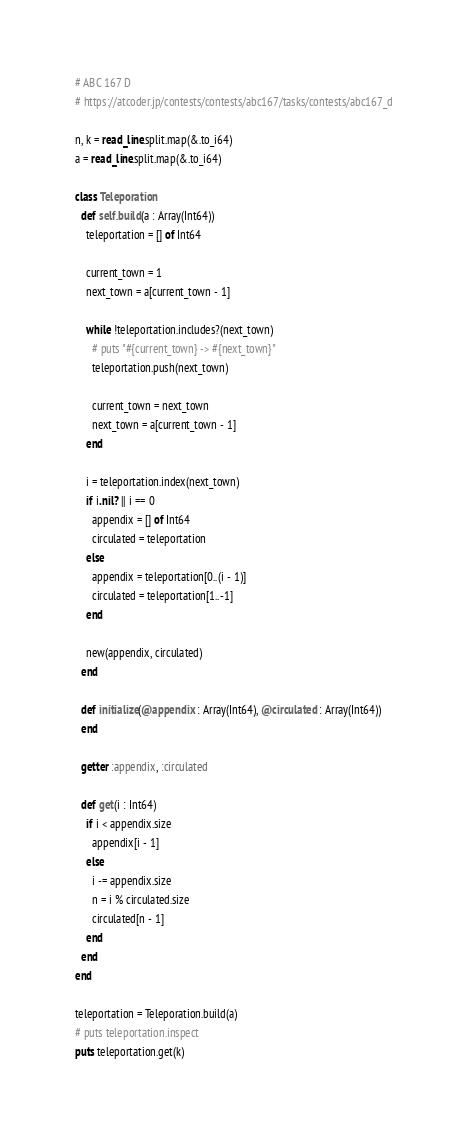<code> <loc_0><loc_0><loc_500><loc_500><_Crystal_># ABC 167 D
# https://atcoder.jp/contests/contests/abc167/tasks/contests/abc167_d

n, k = read_line.split.map(&.to_i64)
a = read_line.split.map(&.to_i64)

class Teleporation
  def self.build(a : Array(Int64))
    teleportation = [] of Int64

    current_town = 1
    next_town = a[current_town - 1]

    while !teleportation.includes?(next_town)
      # puts "#{current_town} -> #{next_town}"
      teleportation.push(next_town)

      current_town = next_town
      next_town = a[current_town - 1]
    end

    i = teleportation.index(next_town)
    if i.nil? || i == 0
      appendix = [] of Int64
      circulated = teleportation
    else
      appendix = teleportation[0..(i - 1)]
      circulated = teleportation[1..-1]
    end

    new(appendix, circulated)
  end

  def initialize(@appendix : Array(Int64), @circulated : Array(Int64))
  end

  getter :appendix, :circulated

  def get(i : Int64)
    if i < appendix.size
      appendix[i - 1]
    else
      i -= appendix.size
      n = i % circulated.size
      circulated[n - 1]
    end
  end
end

teleportation = Teleporation.build(a)
# puts teleportation.inspect
puts teleportation.get(k)
</code> 